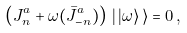<formula> <loc_0><loc_0><loc_500><loc_500>\left ( J ^ { a } _ { n } + \omega ( \bar { J } ^ { a } _ { - n } ) \right ) \, | \, | \omega \rangle \, \rangle = 0 \, ,</formula> 